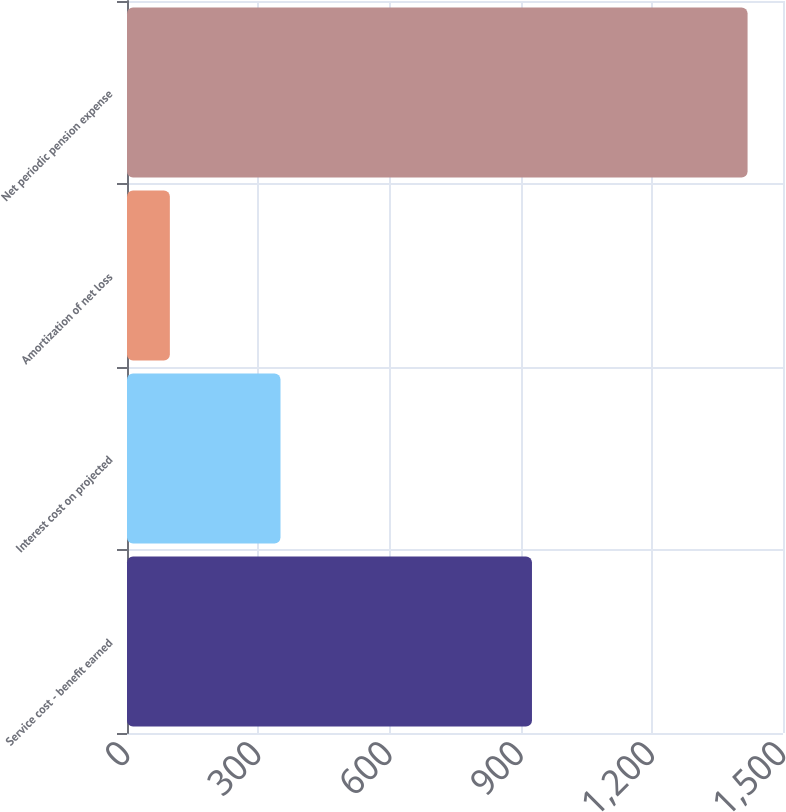Convert chart to OTSL. <chart><loc_0><loc_0><loc_500><loc_500><bar_chart><fcel>Service cost - benefit earned<fcel>Interest cost on projected<fcel>Amortization of net loss<fcel>Net periodic pension expense<nl><fcel>926<fcel>351<fcel>98<fcel>1419<nl></chart> 